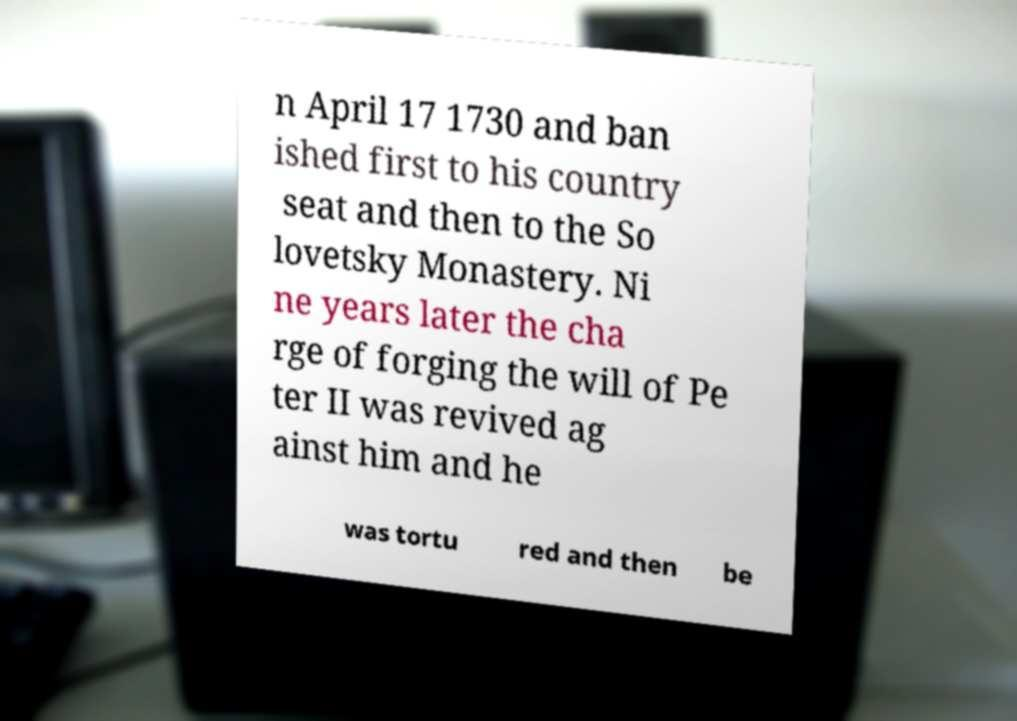Could you extract and type out the text from this image? n April 17 1730 and ban ished first to his country seat and then to the So lovetsky Monastery. Ni ne years later the cha rge of forging the will of Pe ter II was revived ag ainst him and he was tortu red and then be 